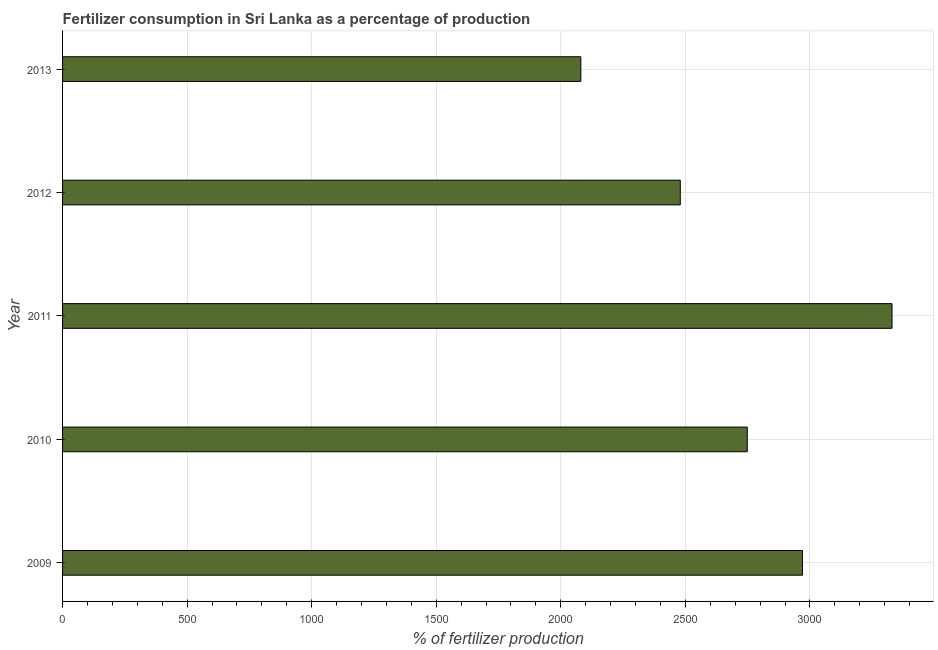Does the graph contain any zero values?
Keep it short and to the point. No. What is the title of the graph?
Ensure brevity in your answer.  Fertilizer consumption in Sri Lanka as a percentage of production. What is the label or title of the X-axis?
Ensure brevity in your answer.  % of fertilizer production. What is the amount of fertilizer consumption in 2013?
Your response must be concise. 2080.5. Across all years, what is the maximum amount of fertilizer consumption?
Provide a short and direct response. 3329.6. Across all years, what is the minimum amount of fertilizer consumption?
Make the answer very short. 2080.5. In which year was the amount of fertilizer consumption maximum?
Ensure brevity in your answer.  2011. In which year was the amount of fertilizer consumption minimum?
Offer a very short reply. 2013. What is the sum of the amount of fertilizer consumption?
Offer a very short reply. 1.36e+04. What is the difference between the amount of fertilizer consumption in 2010 and 2013?
Your answer should be very brief. 668.07. What is the average amount of fertilizer consumption per year?
Your answer should be very brief. 2721.68. What is the median amount of fertilizer consumption?
Your answer should be very brief. 2748.57. What is the ratio of the amount of fertilizer consumption in 2009 to that in 2010?
Your answer should be very brief. 1.08. Is the amount of fertilizer consumption in 2011 less than that in 2013?
Give a very brief answer. No. Is the difference between the amount of fertilizer consumption in 2010 and 2013 greater than the difference between any two years?
Ensure brevity in your answer.  No. What is the difference between the highest and the second highest amount of fertilizer consumption?
Offer a terse response. 359.5. Is the sum of the amount of fertilizer consumption in 2009 and 2013 greater than the maximum amount of fertilizer consumption across all years?
Make the answer very short. Yes. What is the difference between the highest and the lowest amount of fertilizer consumption?
Provide a succinct answer. 1249.1. In how many years, is the amount of fertilizer consumption greater than the average amount of fertilizer consumption taken over all years?
Give a very brief answer. 3. How many bars are there?
Provide a short and direct response. 5. Are all the bars in the graph horizontal?
Provide a short and direct response. Yes. How many years are there in the graph?
Your answer should be very brief. 5. Are the values on the major ticks of X-axis written in scientific E-notation?
Ensure brevity in your answer.  No. What is the % of fertilizer production in 2009?
Offer a very short reply. 2970.1. What is the % of fertilizer production of 2010?
Provide a short and direct response. 2748.57. What is the % of fertilizer production of 2011?
Ensure brevity in your answer.  3329.6. What is the % of fertilizer production of 2012?
Your answer should be compact. 2479.62. What is the % of fertilizer production in 2013?
Give a very brief answer. 2080.5. What is the difference between the % of fertilizer production in 2009 and 2010?
Offer a very short reply. 221.53. What is the difference between the % of fertilizer production in 2009 and 2011?
Make the answer very short. -359.5. What is the difference between the % of fertilizer production in 2009 and 2012?
Offer a very short reply. 490.48. What is the difference between the % of fertilizer production in 2009 and 2013?
Provide a short and direct response. 889.6. What is the difference between the % of fertilizer production in 2010 and 2011?
Your response must be concise. -581.03. What is the difference between the % of fertilizer production in 2010 and 2012?
Provide a succinct answer. 268.95. What is the difference between the % of fertilizer production in 2010 and 2013?
Provide a short and direct response. 668.07. What is the difference between the % of fertilizer production in 2011 and 2012?
Offer a terse response. 849.98. What is the difference between the % of fertilizer production in 2011 and 2013?
Offer a very short reply. 1249.1. What is the difference between the % of fertilizer production in 2012 and 2013?
Ensure brevity in your answer.  399.12. What is the ratio of the % of fertilizer production in 2009 to that in 2010?
Provide a short and direct response. 1.08. What is the ratio of the % of fertilizer production in 2009 to that in 2011?
Your answer should be very brief. 0.89. What is the ratio of the % of fertilizer production in 2009 to that in 2012?
Keep it short and to the point. 1.2. What is the ratio of the % of fertilizer production in 2009 to that in 2013?
Offer a very short reply. 1.43. What is the ratio of the % of fertilizer production in 2010 to that in 2011?
Offer a very short reply. 0.82. What is the ratio of the % of fertilizer production in 2010 to that in 2012?
Provide a short and direct response. 1.11. What is the ratio of the % of fertilizer production in 2010 to that in 2013?
Give a very brief answer. 1.32. What is the ratio of the % of fertilizer production in 2011 to that in 2012?
Keep it short and to the point. 1.34. What is the ratio of the % of fertilizer production in 2012 to that in 2013?
Your answer should be very brief. 1.19. 